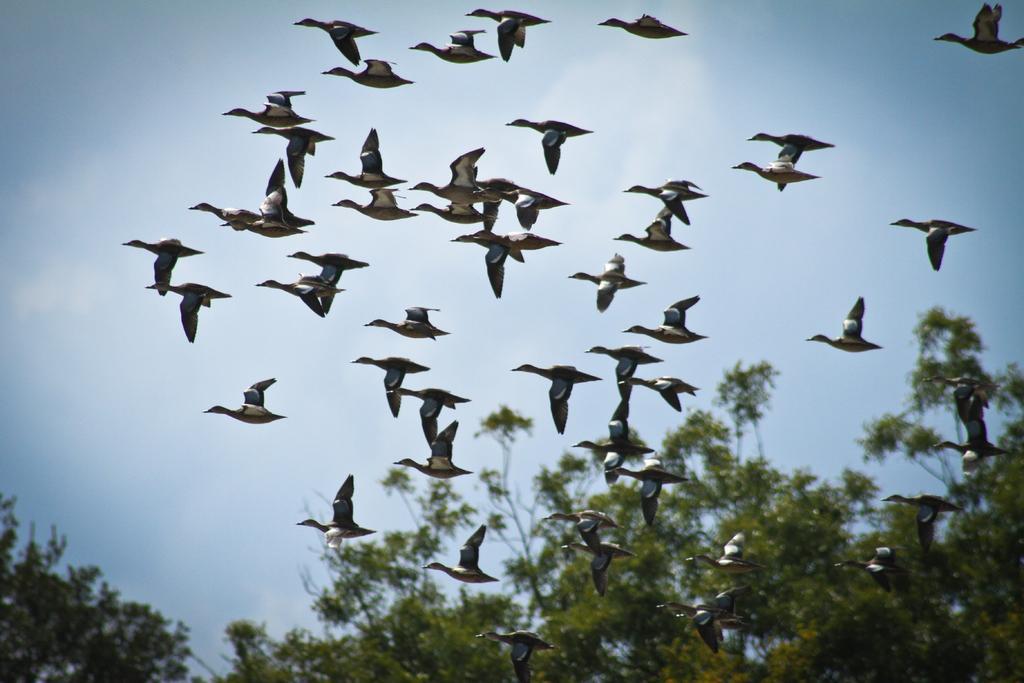Please provide a concise description of this image. In this image we can see a herd of birds. Behind sky is there. Bottom of the image trees are present. 